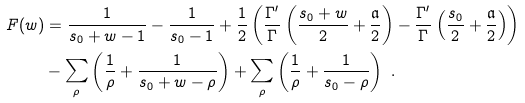Convert formula to latex. <formula><loc_0><loc_0><loc_500><loc_500>F ( w ) & = \frac { 1 } { s _ { 0 } + w - 1 } - \frac { 1 } { s _ { 0 } - 1 } + \frac { 1 } { 2 } \left ( \frac { \Gamma ^ { \prime } } { \Gamma } \left ( \frac { s _ { 0 } + w } { 2 } + \frac { \mathfrak { a } } { 2 } \right ) - \frac { \Gamma ^ { \prime } } { \Gamma } \left ( \frac { s _ { 0 } } { 2 } + \frac { \mathfrak { a } } { 2 } \right ) \right ) \\ & - \sum _ { \rho } \left ( \frac { 1 } { \rho } + \frac { 1 } { s _ { 0 } + w - \rho } \right ) + \sum _ { \rho } \left ( \frac { 1 } { \rho } + \frac { 1 } { s _ { 0 } - \rho } \right ) \ .</formula> 